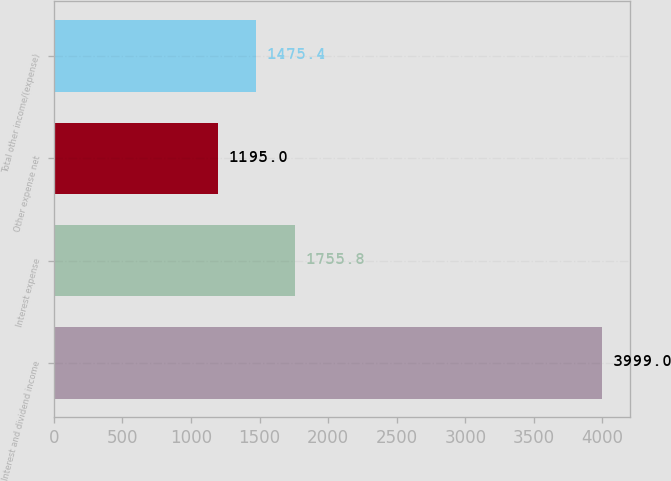<chart> <loc_0><loc_0><loc_500><loc_500><bar_chart><fcel>Interest and dividend income<fcel>Interest expense<fcel>Other expense net<fcel>Total other income/(expense)<nl><fcel>3999<fcel>1755.8<fcel>1195<fcel>1475.4<nl></chart> 